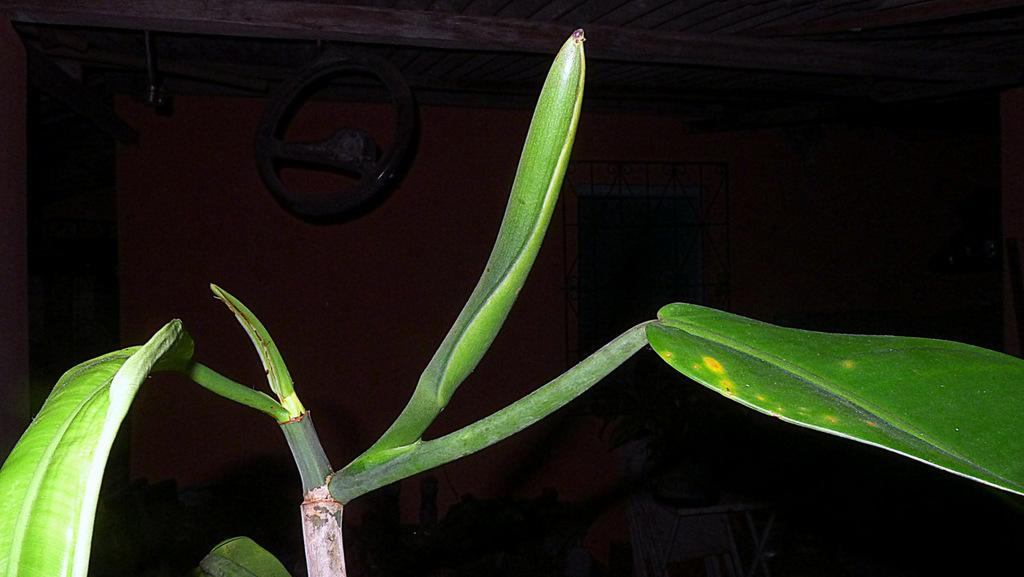What is present in the image? There is a plant in the image. How many leaves does the plant have? The plant has few leaves. What is the color of the background in the image? The background of the image is dark. Can you see a bat hanging from the plant in the image? There is no bat present in the image. Is there an argument happening between the leaves of the plant in the image? The image does not depict an argument between the leaves of the plant. 